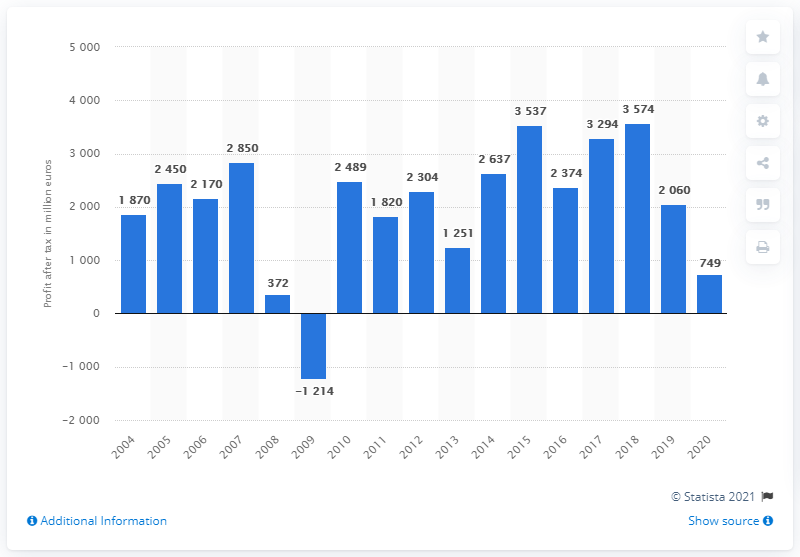Identify some key points in this picture. Bosch's profit after tax in 2020 was 749. 